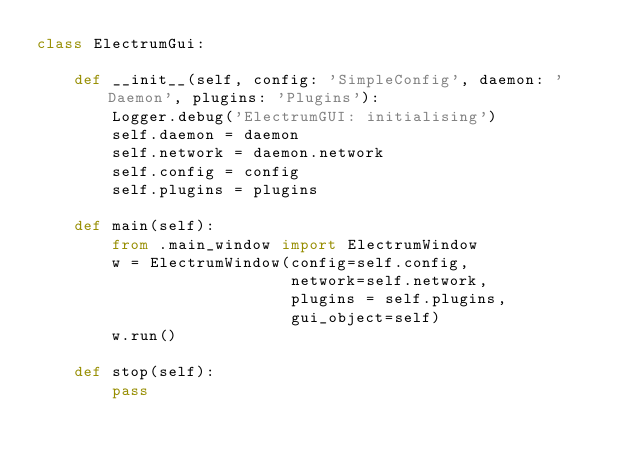<code> <loc_0><loc_0><loc_500><loc_500><_Python_>class ElectrumGui:

    def __init__(self, config: 'SimpleConfig', daemon: 'Daemon', plugins: 'Plugins'):
        Logger.debug('ElectrumGUI: initialising')
        self.daemon = daemon
        self.network = daemon.network
        self.config = config
        self.plugins = plugins

    def main(self):
        from .main_window import ElectrumWindow
        w = ElectrumWindow(config=self.config,
                           network=self.network,
                           plugins = self.plugins,
                           gui_object=self)
        w.run()

    def stop(self):
        pass
</code> 